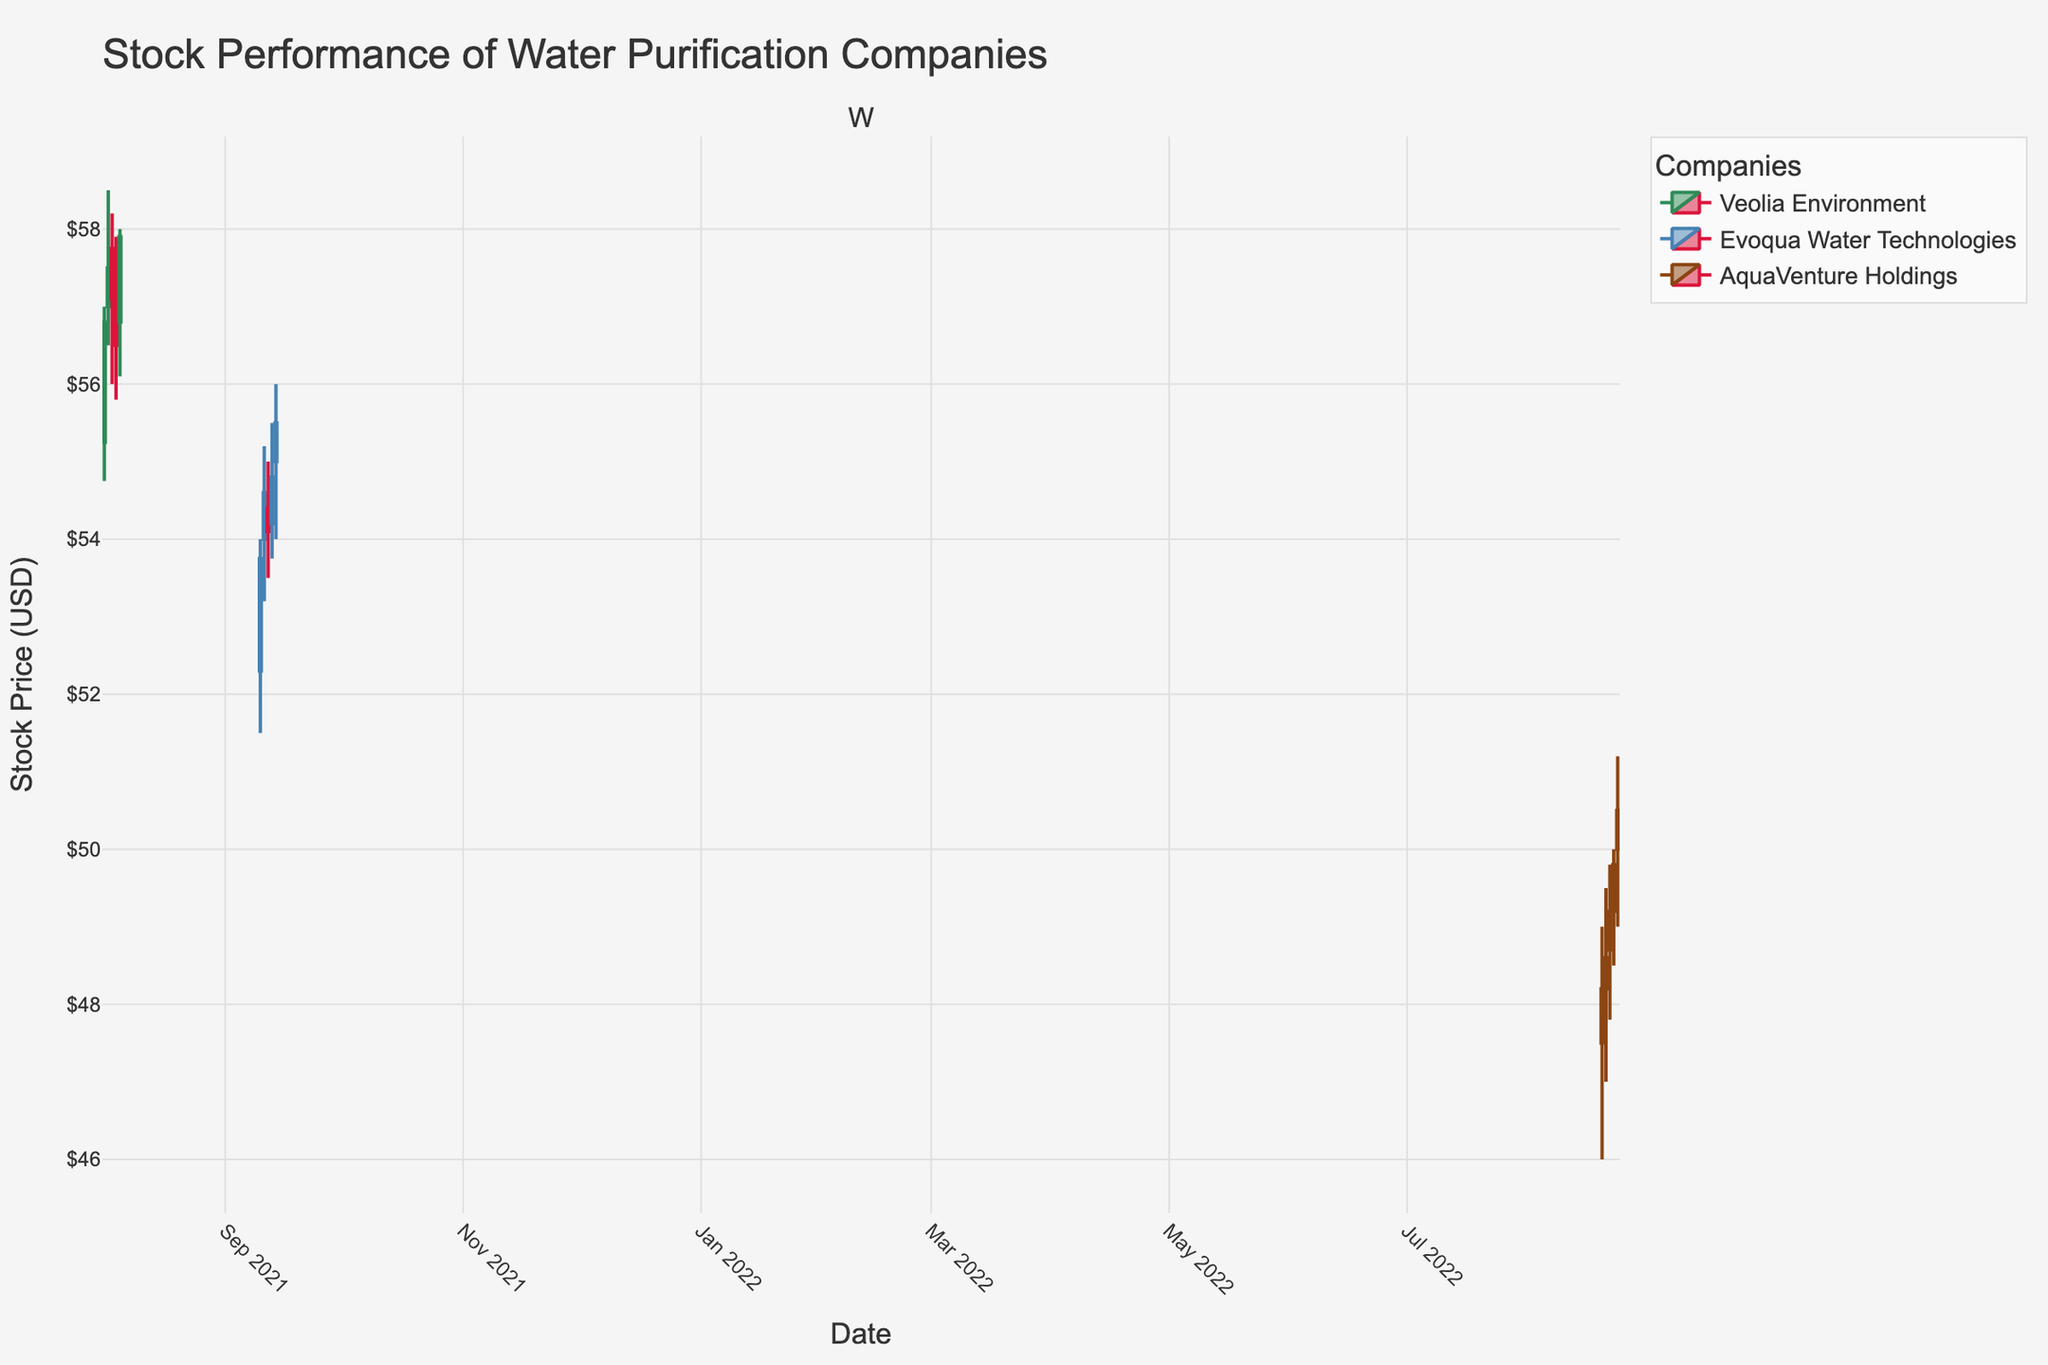What is the title of the candlestick plot? The title is at the top of the figure and reads "Stock Performance of Water Purification Companies".
Answer: Stock Performance of Water Purification Companies How many water purification companies are represented in the plot? There are three water purification companies shown in the plot: Veolia Environment, Evoqua Water Technologies, and AquaVenture Holdings. This is evident because the legend lists these three companies.
Answer: 3 What are the date ranges for the stock data in this plot? By inspecting the x-axis, we can see the dates. The earliest date is August 1, 2021, and the latest date is August 24, 2022.
Answer: August 1, 2021 to August 24, 2022 Which company had the highest trading volume on any given day, and what was that volume? By examining the vertical length of the bars (representing the volume) in the plot closely, we identify August 24, 2022, for AquaVenture Holdings with a volume of 270,000 shares.
Answer: AquaVenture Holdings, 270,000 How does the closing price on August 2, 2021, for Veolia Environment compare to the closing price on August 22, 2022, for AquaVenture Holdings? We identify the closing prices for the given dates from the respective candlesticks. On August 2, 2021, Veolia Environment closed at $57.50. On August 22, 2022, AquaVenture Holdings closed at $49.20. Comparing these, Veolia Environment's closing price is higher.
Answer: Veolia had a higher closing price During which date range did Evoqua Water Technologies experience the highest single-day closing price? By inspecting the candlesticks for Evoqua Water Technologies, the highest closing price is on September 14, 2021, with a price of $55.50. The relevant date range for this company is from September 10, 2021, to September 14, 2021.
Answer: September 10, 2021, to September 14, 2021 What was the average closing price for Veolia Environment over the date range shown? To calculate the average closing price for Veolia Environment, we sum the closing prices (56.80, 57.50, 57.10, 56.50, 57.90) and divide by the number of data points (5): (56.80 + 57.50 + 57.10 + 56.50 + 57.90) / 5 = 57.16.
Answer: 57.16 How many days did AquaVenture Holdings' stock price increase based on the candlestick color? In a candlestick plot, an increase in stock price is typically shown in green. AquaVenture Holdings shows price increases on four days: August 21, August 22, August 23, and August 24.
Answer: 4 Which company had the largest single-day drop in stock price and on which date did it occur? We need to find the largest difference between the opening and closing prices for each company. Veolia Environment on August 4, 2021, had a drop from $57.25 to $56.50, which is a $0.75 drop. Evoqua Water Technologies did not have a larger drop. AquaVenture Holdings' largest drop was less. Hence, Veolia's $0.75 drop on August 4, 2021, is the largest.
Answer: Veolia Environment, August 4, 2021 